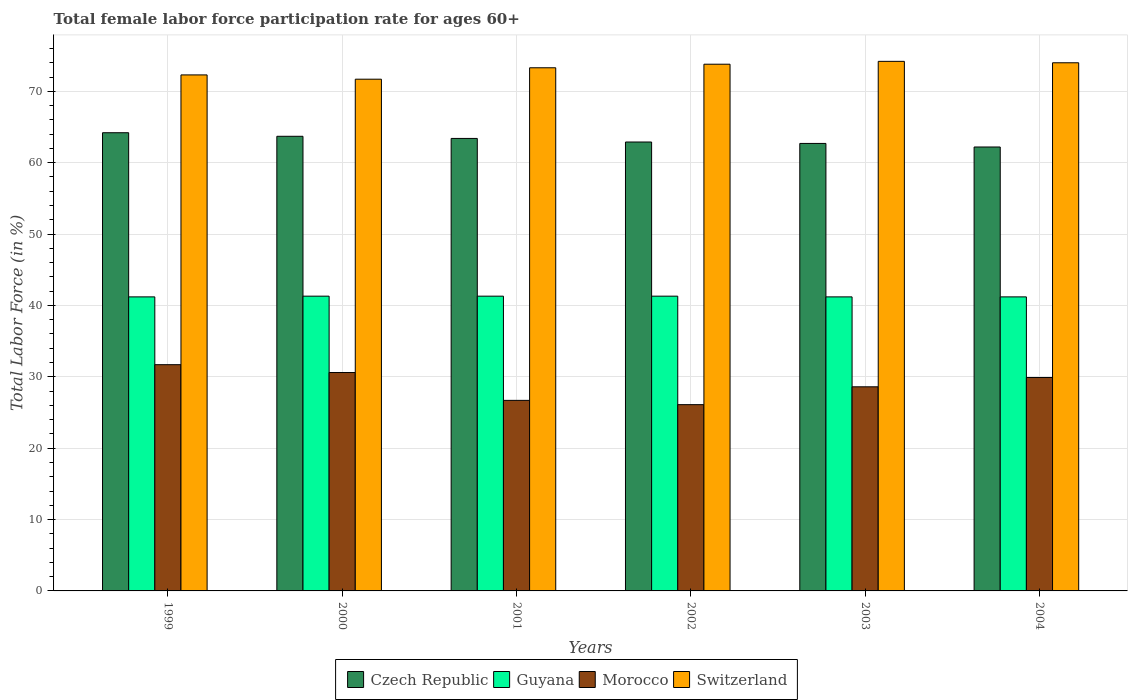How many different coloured bars are there?
Offer a terse response. 4. How many groups of bars are there?
Offer a very short reply. 6. Are the number of bars per tick equal to the number of legend labels?
Your answer should be compact. Yes. Are the number of bars on each tick of the X-axis equal?
Make the answer very short. Yes. How many bars are there on the 6th tick from the left?
Your answer should be very brief. 4. What is the label of the 1st group of bars from the left?
Give a very brief answer. 1999. What is the female labor force participation rate in Morocco in 2003?
Your answer should be compact. 28.6. Across all years, what is the maximum female labor force participation rate in Morocco?
Offer a terse response. 31.7. Across all years, what is the minimum female labor force participation rate in Morocco?
Ensure brevity in your answer.  26.1. In which year was the female labor force participation rate in Czech Republic maximum?
Offer a terse response. 1999. What is the total female labor force participation rate in Guyana in the graph?
Offer a terse response. 247.5. What is the difference between the female labor force participation rate in Morocco in 2000 and the female labor force participation rate in Switzerland in 2001?
Make the answer very short. -42.7. What is the average female labor force participation rate in Switzerland per year?
Ensure brevity in your answer.  73.22. In the year 2001, what is the difference between the female labor force participation rate in Guyana and female labor force participation rate in Czech Republic?
Provide a short and direct response. -22.1. What is the ratio of the female labor force participation rate in Guyana in 2001 to that in 2003?
Ensure brevity in your answer.  1. Is the difference between the female labor force participation rate in Guyana in 2001 and 2004 greater than the difference between the female labor force participation rate in Czech Republic in 2001 and 2004?
Your answer should be compact. No. What is the difference between the highest and the lowest female labor force participation rate in Czech Republic?
Offer a very short reply. 2. Is it the case that in every year, the sum of the female labor force participation rate in Czech Republic and female labor force participation rate in Switzerland is greater than the sum of female labor force participation rate in Morocco and female labor force participation rate in Guyana?
Your answer should be compact. Yes. What does the 3rd bar from the left in 2004 represents?
Offer a terse response. Morocco. What does the 4th bar from the right in 1999 represents?
Your response must be concise. Czech Republic. Is it the case that in every year, the sum of the female labor force participation rate in Czech Republic and female labor force participation rate in Switzerland is greater than the female labor force participation rate in Morocco?
Make the answer very short. Yes. How many bars are there?
Offer a very short reply. 24. What is the difference between two consecutive major ticks on the Y-axis?
Offer a terse response. 10. Are the values on the major ticks of Y-axis written in scientific E-notation?
Offer a terse response. No. Does the graph contain any zero values?
Your answer should be compact. No. Where does the legend appear in the graph?
Offer a very short reply. Bottom center. How many legend labels are there?
Provide a succinct answer. 4. How are the legend labels stacked?
Offer a very short reply. Horizontal. What is the title of the graph?
Ensure brevity in your answer.  Total female labor force participation rate for ages 60+. Does "Eritrea" appear as one of the legend labels in the graph?
Offer a very short reply. No. What is the label or title of the X-axis?
Your response must be concise. Years. What is the label or title of the Y-axis?
Provide a succinct answer. Total Labor Force (in %). What is the Total Labor Force (in %) in Czech Republic in 1999?
Provide a succinct answer. 64.2. What is the Total Labor Force (in %) of Guyana in 1999?
Ensure brevity in your answer.  41.2. What is the Total Labor Force (in %) in Morocco in 1999?
Keep it short and to the point. 31.7. What is the Total Labor Force (in %) of Switzerland in 1999?
Your answer should be compact. 72.3. What is the Total Labor Force (in %) of Czech Republic in 2000?
Provide a succinct answer. 63.7. What is the Total Labor Force (in %) of Guyana in 2000?
Provide a short and direct response. 41.3. What is the Total Labor Force (in %) of Morocco in 2000?
Your answer should be compact. 30.6. What is the Total Labor Force (in %) of Switzerland in 2000?
Provide a succinct answer. 71.7. What is the Total Labor Force (in %) of Czech Republic in 2001?
Offer a very short reply. 63.4. What is the Total Labor Force (in %) of Guyana in 2001?
Keep it short and to the point. 41.3. What is the Total Labor Force (in %) of Morocco in 2001?
Offer a very short reply. 26.7. What is the Total Labor Force (in %) in Switzerland in 2001?
Give a very brief answer. 73.3. What is the Total Labor Force (in %) in Czech Republic in 2002?
Offer a very short reply. 62.9. What is the Total Labor Force (in %) of Guyana in 2002?
Give a very brief answer. 41.3. What is the Total Labor Force (in %) of Morocco in 2002?
Offer a terse response. 26.1. What is the Total Labor Force (in %) of Switzerland in 2002?
Make the answer very short. 73.8. What is the Total Labor Force (in %) in Czech Republic in 2003?
Keep it short and to the point. 62.7. What is the Total Labor Force (in %) of Guyana in 2003?
Provide a succinct answer. 41.2. What is the Total Labor Force (in %) in Morocco in 2003?
Provide a succinct answer. 28.6. What is the Total Labor Force (in %) in Switzerland in 2003?
Provide a succinct answer. 74.2. What is the Total Labor Force (in %) of Czech Republic in 2004?
Provide a short and direct response. 62.2. What is the Total Labor Force (in %) of Guyana in 2004?
Your response must be concise. 41.2. What is the Total Labor Force (in %) of Morocco in 2004?
Your answer should be very brief. 29.9. What is the Total Labor Force (in %) of Switzerland in 2004?
Ensure brevity in your answer.  74. Across all years, what is the maximum Total Labor Force (in %) in Czech Republic?
Keep it short and to the point. 64.2. Across all years, what is the maximum Total Labor Force (in %) of Guyana?
Give a very brief answer. 41.3. Across all years, what is the maximum Total Labor Force (in %) in Morocco?
Make the answer very short. 31.7. Across all years, what is the maximum Total Labor Force (in %) of Switzerland?
Your response must be concise. 74.2. Across all years, what is the minimum Total Labor Force (in %) of Czech Republic?
Make the answer very short. 62.2. Across all years, what is the minimum Total Labor Force (in %) in Guyana?
Your answer should be compact. 41.2. Across all years, what is the minimum Total Labor Force (in %) of Morocco?
Ensure brevity in your answer.  26.1. Across all years, what is the minimum Total Labor Force (in %) of Switzerland?
Ensure brevity in your answer.  71.7. What is the total Total Labor Force (in %) of Czech Republic in the graph?
Your answer should be very brief. 379.1. What is the total Total Labor Force (in %) of Guyana in the graph?
Give a very brief answer. 247.5. What is the total Total Labor Force (in %) in Morocco in the graph?
Your answer should be compact. 173.6. What is the total Total Labor Force (in %) of Switzerland in the graph?
Keep it short and to the point. 439.3. What is the difference between the Total Labor Force (in %) of Morocco in 1999 and that in 2000?
Give a very brief answer. 1.1. What is the difference between the Total Labor Force (in %) of Switzerland in 1999 and that in 2000?
Give a very brief answer. 0.6. What is the difference between the Total Labor Force (in %) in Guyana in 1999 and that in 2001?
Your response must be concise. -0.1. What is the difference between the Total Labor Force (in %) in Czech Republic in 1999 and that in 2002?
Ensure brevity in your answer.  1.3. What is the difference between the Total Labor Force (in %) in Switzerland in 1999 and that in 2002?
Give a very brief answer. -1.5. What is the difference between the Total Labor Force (in %) of Czech Republic in 1999 and that in 2003?
Give a very brief answer. 1.5. What is the difference between the Total Labor Force (in %) of Guyana in 1999 and that in 2003?
Provide a short and direct response. 0. What is the difference between the Total Labor Force (in %) of Guyana in 1999 and that in 2004?
Provide a succinct answer. 0. What is the difference between the Total Labor Force (in %) of Czech Republic in 2000 and that in 2001?
Give a very brief answer. 0.3. What is the difference between the Total Labor Force (in %) in Morocco in 2000 and that in 2001?
Keep it short and to the point. 3.9. What is the difference between the Total Labor Force (in %) in Morocco in 2000 and that in 2002?
Give a very brief answer. 4.5. What is the difference between the Total Labor Force (in %) in Czech Republic in 2000 and that in 2003?
Offer a terse response. 1. What is the difference between the Total Labor Force (in %) of Morocco in 2000 and that in 2004?
Your response must be concise. 0.7. What is the difference between the Total Labor Force (in %) of Morocco in 2001 and that in 2002?
Make the answer very short. 0.6. What is the difference between the Total Labor Force (in %) of Switzerland in 2001 and that in 2002?
Give a very brief answer. -0.5. What is the difference between the Total Labor Force (in %) in Czech Republic in 2001 and that in 2004?
Your answer should be very brief. 1.2. What is the difference between the Total Labor Force (in %) in Morocco in 2001 and that in 2004?
Provide a succinct answer. -3.2. What is the difference between the Total Labor Force (in %) of Switzerland in 2001 and that in 2004?
Make the answer very short. -0.7. What is the difference between the Total Labor Force (in %) in Switzerland in 2002 and that in 2003?
Keep it short and to the point. -0.4. What is the difference between the Total Labor Force (in %) of Czech Republic in 2002 and that in 2004?
Give a very brief answer. 0.7. What is the difference between the Total Labor Force (in %) in Guyana in 2002 and that in 2004?
Provide a short and direct response. 0.1. What is the difference between the Total Labor Force (in %) in Switzerland in 2003 and that in 2004?
Offer a terse response. 0.2. What is the difference between the Total Labor Force (in %) in Czech Republic in 1999 and the Total Labor Force (in %) in Guyana in 2000?
Make the answer very short. 22.9. What is the difference between the Total Labor Force (in %) of Czech Republic in 1999 and the Total Labor Force (in %) of Morocco in 2000?
Provide a short and direct response. 33.6. What is the difference between the Total Labor Force (in %) of Guyana in 1999 and the Total Labor Force (in %) of Switzerland in 2000?
Provide a short and direct response. -30.5. What is the difference between the Total Labor Force (in %) in Czech Republic in 1999 and the Total Labor Force (in %) in Guyana in 2001?
Provide a succinct answer. 22.9. What is the difference between the Total Labor Force (in %) in Czech Republic in 1999 and the Total Labor Force (in %) in Morocco in 2001?
Offer a very short reply. 37.5. What is the difference between the Total Labor Force (in %) of Guyana in 1999 and the Total Labor Force (in %) of Morocco in 2001?
Make the answer very short. 14.5. What is the difference between the Total Labor Force (in %) in Guyana in 1999 and the Total Labor Force (in %) in Switzerland in 2001?
Offer a terse response. -32.1. What is the difference between the Total Labor Force (in %) of Morocco in 1999 and the Total Labor Force (in %) of Switzerland in 2001?
Give a very brief answer. -41.6. What is the difference between the Total Labor Force (in %) in Czech Republic in 1999 and the Total Labor Force (in %) in Guyana in 2002?
Offer a terse response. 22.9. What is the difference between the Total Labor Force (in %) of Czech Republic in 1999 and the Total Labor Force (in %) of Morocco in 2002?
Offer a terse response. 38.1. What is the difference between the Total Labor Force (in %) of Guyana in 1999 and the Total Labor Force (in %) of Switzerland in 2002?
Ensure brevity in your answer.  -32.6. What is the difference between the Total Labor Force (in %) of Morocco in 1999 and the Total Labor Force (in %) of Switzerland in 2002?
Ensure brevity in your answer.  -42.1. What is the difference between the Total Labor Force (in %) of Czech Republic in 1999 and the Total Labor Force (in %) of Guyana in 2003?
Give a very brief answer. 23. What is the difference between the Total Labor Force (in %) of Czech Republic in 1999 and the Total Labor Force (in %) of Morocco in 2003?
Your answer should be very brief. 35.6. What is the difference between the Total Labor Force (in %) in Czech Republic in 1999 and the Total Labor Force (in %) in Switzerland in 2003?
Provide a short and direct response. -10. What is the difference between the Total Labor Force (in %) in Guyana in 1999 and the Total Labor Force (in %) in Morocco in 2003?
Offer a very short reply. 12.6. What is the difference between the Total Labor Force (in %) of Guyana in 1999 and the Total Labor Force (in %) of Switzerland in 2003?
Give a very brief answer. -33. What is the difference between the Total Labor Force (in %) of Morocco in 1999 and the Total Labor Force (in %) of Switzerland in 2003?
Provide a succinct answer. -42.5. What is the difference between the Total Labor Force (in %) of Czech Republic in 1999 and the Total Labor Force (in %) of Morocco in 2004?
Provide a succinct answer. 34.3. What is the difference between the Total Labor Force (in %) of Guyana in 1999 and the Total Labor Force (in %) of Switzerland in 2004?
Provide a succinct answer. -32.8. What is the difference between the Total Labor Force (in %) of Morocco in 1999 and the Total Labor Force (in %) of Switzerland in 2004?
Offer a terse response. -42.3. What is the difference between the Total Labor Force (in %) of Czech Republic in 2000 and the Total Labor Force (in %) of Guyana in 2001?
Your answer should be compact. 22.4. What is the difference between the Total Labor Force (in %) in Czech Republic in 2000 and the Total Labor Force (in %) in Switzerland in 2001?
Provide a short and direct response. -9.6. What is the difference between the Total Labor Force (in %) in Guyana in 2000 and the Total Labor Force (in %) in Switzerland in 2001?
Ensure brevity in your answer.  -32. What is the difference between the Total Labor Force (in %) of Morocco in 2000 and the Total Labor Force (in %) of Switzerland in 2001?
Make the answer very short. -42.7. What is the difference between the Total Labor Force (in %) of Czech Republic in 2000 and the Total Labor Force (in %) of Guyana in 2002?
Your answer should be compact. 22.4. What is the difference between the Total Labor Force (in %) in Czech Republic in 2000 and the Total Labor Force (in %) in Morocco in 2002?
Your response must be concise. 37.6. What is the difference between the Total Labor Force (in %) in Czech Republic in 2000 and the Total Labor Force (in %) in Switzerland in 2002?
Keep it short and to the point. -10.1. What is the difference between the Total Labor Force (in %) of Guyana in 2000 and the Total Labor Force (in %) of Morocco in 2002?
Provide a short and direct response. 15.2. What is the difference between the Total Labor Force (in %) in Guyana in 2000 and the Total Labor Force (in %) in Switzerland in 2002?
Ensure brevity in your answer.  -32.5. What is the difference between the Total Labor Force (in %) of Morocco in 2000 and the Total Labor Force (in %) of Switzerland in 2002?
Ensure brevity in your answer.  -43.2. What is the difference between the Total Labor Force (in %) of Czech Republic in 2000 and the Total Labor Force (in %) of Morocco in 2003?
Make the answer very short. 35.1. What is the difference between the Total Labor Force (in %) in Czech Republic in 2000 and the Total Labor Force (in %) in Switzerland in 2003?
Make the answer very short. -10.5. What is the difference between the Total Labor Force (in %) in Guyana in 2000 and the Total Labor Force (in %) in Morocco in 2003?
Make the answer very short. 12.7. What is the difference between the Total Labor Force (in %) of Guyana in 2000 and the Total Labor Force (in %) of Switzerland in 2003?
Your answer should be compact. -32.9. What is the difference between the Total Labor Force (in %) in Morocco in 2000 and the Total Labor Force (in %) in Switzerland in 2003?
Your answer should be very brief. -43.6. What is the difference between the Total Labor Force (in %) of Czech Republic in 2000 and the Total Labor Force (in %) of Morocco in 2004?
Your response must be concise. 33.8. What is the difference between the Total Labor Force (in %) of Guyana in 2000 and the Total Labor Force (in %) of Morocco in 2004?
Make the answer very short. 11.4. What is the difference between the Total Labor Force (in %) in Guyana in 2000 and the Total Labor Force (in %) in Switzerland in 2004?
Your answer should be very brief. -32.7. What is the difference between the Total Labor Force (in %) in Morocco in 2000 and the Total Labor Force (in %) in Switzerland in 2004?
Provide a short and direct response. -43.4. What is the difference between the Total Labor Force (in %) in Czech Republic in 2001 and the Total Labor Force (in %) in Guyana in 2002?
Keep it short and to the point. 22.1. What is the difference between the Total Labor Force (in %) of Czech Republic in 2001 and the Total Labor Force (in %) of Morocco in 2002?
Your answer should be compact. 37.3. What is the difference between the Total Labor Force (in %) of Czech Republic in 2001 and the Total Labor Force (in %) of Switzerland in 2002?
Ensure brevity in your answer.  -10.4. What is the difference between the Total Labor Force (in %) in Guyana in 2001 and the Total Labor Force (in %) in Switzerland in 2002?
Your response must be concise. -32.5. What is the difference between the Total Labor Force (in %) of Morocco in 2001 and the Total Labor Force (in %) of Switzerland in 2002?
Offer a terse response. -47.1. What is the difference between the Total Labor Force (in %) of Czech Republic in 2001 and the Total Labor Force (in %) of Morocco in 2003?
Your answer should be very brief. 34.8. What is the difference between the Total Labor Force (in %) in Czech Republic in 2001 and the Total Labor Force (in %) in Switzerland in 2003?
Ensure brevity in your answer.  -10.8. What is the difference between the Total Labor Force (in %) of Guyana in 2001 and the Total Labor Force (in %) of Morocco in 2003?
Ensure brevity in your answer.  12.7. What is the difference between the Total Labor Force (in %) in Guyana in 2001 and the Total Labor Force (in %) in Switzerland in 2003?
Provide a succinct answer. -32.9. What is the difference between the Total Labor Force (in %) of Morocco in 2001 and the Total Labor Force (in %) of Switzerland in 2003?
Provide a succinct answer. -47.5. What is the difference between the Total Labor Force (in %) of Czech Republic in 2001 and the Total Labor Force (in %) of Morocco in 2004?
Make the answer very short. 33.5. What is the difference between the Total Labor Force (in %) of Czech Republic in 2001 and the Total Labor Force (in %) of Switzerland in 2004?
Keep it short and to the point. -10.6. What is the difference between the Total Labor Force (in %) of Guyana in 2001 and the Total Labor Force (in %) of Morocco in 2004?
Provide a succinct answer. 11.4. What is the difference between the Total Labor Force (in %) of Guyana in 2001 and the Total Labor Force (in %) of Switzerland in 2004?
Provide a short and direct response. -32.7. What is the difference between the Total Labor Force (in %) of Morocco in 2001 and the Total Labor Force (in %) of Switzerland in 2004?
Give a very brief answer. -47.3. What is the difference between the Total Labor Force (in %) of Czech Republic in 2002 and the Total Labor Force (in %) of Guyana in 2003?
Keep it short and to the point. 21.7. What is the difference between the Total Labor Force (in %) of Czech Republic in 2002 and the Total Labor Force (in %) of Morocco in 2003?
Ensure brevity in your answer.  34.3. What is the difference between the Total Labor Force (in %) of Czech Republic in 2002 and the Total Labor Force (in %) of Switzerland in 2003?
Make the answer very short. -11.3. What is the difference between the Total Labor Force (in %) in Guyana in 2002 and the Total Labor Force (in %) in Morocco in 2003?
Make the answer very short. 12.7. What is the difference between the Total Labor Force (in %) in Guyana in 2002 and the Total Labor Force (in %) in Switzerland in 2003?
Give a very brief answer. -32.9. What is the difference between the Total Labor Force (in %) in Morocco in 2002 and the Total Labor Force (in %) in Switzerland in 2003?
Your answer should be compact. -48.1. What is the difference between the Total Labor Force (in %) of Czech Republic in 2002 and the Total Labor Force (in %) of Guyana in 2004?
Keep it short and to the point. 21.7. What is the difference between the Total Labor Force (in %) in Czech Republic in 2002 and the Total Labor Force (in %) in Switzerland in 2004?
Make the answer very short. -11.1. What is the difference between the Total Labor Force (in %) of Guyana in 2002 and the Total Labor Force (in %) of Switzerland in 2004?
Make the answer very short. -32.7. What is the difference between the Total Labor Force (in %) of Morocco in 2002 and the Total Labor Force (in %) of Switzerland in 2004?
Your answer should be very brief. -47.9. What is the difference between the Total Labor Force (in %) of Czech Republic in 2003 and the Total Labor Force (in %) of Morocco in 2004?
Offer a very short reply. 32.8. What is the difference between the Total Labor Force (in %) of Czech Republic in 2003 and the Total Labor Force (in %) of Switzerland in 2004?
Give a very brief answer. -11.3. What is the difference between the Total Labor Force (in %) in Guyana in 2003 and the Total Labor Force (in %) in Switzerland in 2004?
Offer a terse response. -32.8. What is the difference between the Total Labor Force (in %) of Morocco in 2003 and the Total Labor Force (in %) of Switzerland in 2004?
Provide a short and direct response. -45.4. What is the average Total Labor Force (in %) of Czech Republic per year?
Your answer should be very brief. 63.18. What is the average Total Labor Force (in %) of Guyana per year?
Offer a terse response. 41.25. What is the average Total Labor Force (in %) of Morocco per year?
Provide a succinct answer. 28.93. What is the average Total Labor Force (in %) in Switzerland per year?
Offer a very short reply. 73.22. In the year 1999, what is the difference between the Total Labor Force (in %) of Czech Republic and Total Labor Force (in %) of Morocco?
Provide a short and direct response. 32.5. In the year 1999, what is the difference between the Total Labor Force (in %) in Czech Republic and Total Labor Force (in %) in Switzerland?
Ensure brevity in your answer.  -8.1. In the year 1999, what is the difference between the Total Labor Force (in %) of Guyana and Total Labor Force (in %) of Switzerland?
Offer a very short reply. -31.1. In the year 1999, what is the difference between the Total Labor Force (in %) in Morocco and Total Labor Force (in %) in Switzerland?
Make the answer very short. -40.6. In the year 2000, what is the difference between the Total Labor Force (in %) in Czech Republic and Total Labor Force (in %) in Guyana?
Ensure brevity in your answer.  22.4. In the year 2000, what is the difference between the Total Labor Force (in %) of Czech Republic and Total Labor Force (in %) of Morocco?
Make the answer very short. 33.1. In the year 2000, what is the difference between the Total Labor Force (in %) of Guyana and Total Labor Force (in %) of Morocco?
Make the answer very short. 10.7. In the year 2000, what is the difference between the Total Labor Force (in %) in Guyana and Total Labor Force (in %) in Switzerland?
Your response must be concise. -30.4. In the year 2000, what is the difference between the Total Labor Force (in %) in Morocco and Total Labor Force (in %) in Switzerland?
Offer a terse response. -41.1. In the year 2001, what is the difference between the Total Labor Force (in %) in Czech Republic and Total Labor Force (in %) in Guyana?
Make the answer very short. 22.1. In the year 2001, what is the difference between the Total Labor Force (in %) of Czech Republic and Total Labor Force (in %) of Morocco?
Make the answer very short. 36.7. In the year 2001, what is the difference between the Total Labor Force (in %) in Czech Republic and Total Labor Force (in %) in Switzerland?
Provide a succinct answer. -9.9. In the year 2001, what is the difference between the Total Labor Force (in %) in Guyana and Total Labor Force (in %) in Morocco?
Provide a short and direct response. 14.6. In the year 2001, what is the difference between the Total Labor Force (in %) of Guyana and Total Labor Force (in %) of Switzerland?
Offer a very short reply. -32. In the year 2001, what is the difference between the Total Labor Force (in %) in Morocco and Total Labor Force (in %) in Switzerland?
Your response must be concise. -46.6. In the year 2002, what is the difference between the Total Labor Force (in %) of Czech Republic and Total Labor Force (in %) of Guyana?
Make the answer very short. 21.6. In the year 2002, what is the difference between the Total Labor Force (in %) of Czech Republic and Total Labor Force (in %) of Morocco?
Keep it short and to the point. 36.8. In the year 2002, what is the difference between the Total Labor Force (in %) of Czech Republic and Total Labor Force (in %) of Switzerland?
Provide a succinct answer. -10.9. In the year 2002, what is the difference between the Total Labor Force (in %) in Guyana and Total Labor Force (in %) in Morocco?
Your response must be concise. 15.2. In the year 2002, what is the difference between the Total Labor Force (in %) of Guyana and Total Labor Force (in %) of Switzerland?
Your answer should be very brief. -32.5. In the year 2002, what is the difference between the Total Labor Force (in %) in Morocco and Total Labor Force (in %) in Switzerland?
Give a very brief answer. -47.7. In the year 2003, what is the difference between the Total Labor Force (in %) of Czech Republic and Total Labor Force (in %) of Morocco?
Provide a succinct answer. 34.1. In the year 2003, what is the difference between the Total Labor Force (in %) in Czech Republic and Total Labor Force (in %) in Switzerland?
Offer a terse response. -11.5. In the year 2003, what is the difference between the Total Labor Force (in %) in Guyana and Total Labor Force (in %) in Morocco?
Offer a terse response. 12.6. In the year 2003, what is the difference between the Total Labor Force (in %) of Guyana and Total Labor Force (in %) of Switzerland?
Ensure brevity in your answer.  -33. In the year 2003, what is the difference between the Total Labor Force (in %) of Morocco and Total Labor Force (in %) of Switzerland?
Your answer should be very brief. -45.6. In the year 2004, what is the difference between the Total Labor Force (in %) in Czech Republic and Total Labor Force (in %) in Guyana?
Provide a short and direct response. 21. In the year 2004, what is the difference between the Total Labor Force (in %) in Czech Republic and Total Labor Force (in %) in Morocco?
Ensure brevity in your answer.  32.3. In the year 2004, what is the difference between the Total Labor Force (in %) in Czech Republic and Total Labor Force (in %) in Switzerland?
Ensure brevity in your answer.  -11.8. In the year 2004, what is the difference between the Total Labor Force (in %) of Guyana and Total Labor Force (in %) of Switzerland?
Make the answer very short. -32.8. In the year 2004, what is the difference between the Total Labor Force (in %) in Morocco and Total Labor Force (in %) in Switzerland?
Your response must be concise. -44.1. What is the ratio of the Total Labor Force (in %) in Morocco in 1999 to that in 2000?
Make the answer very short. 1.04. What is the ratio of the Total Labor Force (in %) of Switzerland in 1999 to that in 2000?
Your answer should be very brief. 1.01. What is the ratio of the Total Labor Force (in %) of Czech Republic in 1999 to that in 2001?
Give a very brief answer. 1.01. What is the ratio of the Total Labor Force (in %) of Guyana in 1999 to that in 2001?
Give a very brief answer. 1. What is the ratio of the Total Labor Force (in %) in Morocco in 1999 to that in 2001?
Offer a terse response. 1.19. What is the ratio of the Total Labor Force (in %) of Switzerland in 1999 to that in 2001?
Offer a terse response. 0.99. What is the ratio of the Total Labor Force (in %) of Czech Republic in 1999 to that in 2002?
Offer a very short reply. 1.02. What is the ratio of the Total Labor Force (in %) of Guyana in 1999 to that in 2002?
Make the answer very short. 1. What is the ratio of the Total Labor Force (in %) of Morocco in 1999 to that in 2002?
Offer a very short reply. 1.21. What is the ratio of the Total Labor Force (in %) in Switzerland in 1999 to that in 2002?
Make the answer very short. 0.98. What is the ratio of the Total Labor Force (in %) in Czech Republic in 1999 to that in 2003?
Your answer should be very brief. 1.02. What is the ratio of the Total Labor Force (in %) of Guyana in 1999 to that in 2003?
Offer a very short reply. 1. What is the ratio of the Total Labor Force (in %) of Morocco in 1999 to that in 2003?
Make the answer very short. 1.11. What is the ratio of the Total Labor Force (in %) of Switzerland in 1999 to that in 2003?
Make the answer very short. 0.97. What is the ratio of the Total Labor Force (in %) of Czech Republic in 1999 to that in 2004?
Keep it short and to the point. 1.03. What is the ratio of the Total Labor Force (in %) in Guyana in 1999 to that in 2004?
Your answer should be compact. 1. What is the ratio of the Total Labor Force (in %) of Morocco in 1999 to that in 2004?
Your answer should be compact. 1.06. What is the ratio of the Total Labor Force (in %) in Switzerland in 1999 to that in 2004?
Make the answer very short. 0.98. What is the ratio of the Total Labor Force (in %) in Guyana in 2000 to that in 2001?
Ensure brevity in your answer.  1. What is the ratio of the Total Labor Force (in %) of Morocco in 2000 to that in 2001?
Ensure brevity in your answer.  1.15. What is the ratio of the Total Labor Force (in %) of Switzerland in 2000 to that in 2001?
Make the answer very short. 0.98. What is the ratio of the Total Labor Force (in %) in Czech Republic in 2000 to that in 2002?
Make the answer very short. 1.01. What is the ratio of the Total Labor Force (in %) in Morocco in 2000 to that in 2002?
Keep it short and to the point. 1.17. What is the ratio of the Total Labor Force (in %) of Switzerland in 2000 to that in 2002?
Give a very brief answer. 0.97. What is the ratio of the Total Labor Force (in %) of Czech Republic in 2000 to that in 2003?
Your answer should be compact. 1.02. What is the ratio of the Total Labor Force (in %) in Morocco in 2000 to that in 2003?
Your response must be concise. 1.07. What is the ratio of the Total Labor Force (in %) of Switzerland in 2000 to that in 2003?
Keep it short and to the point. 0.97. What is the ratio of the Total Labor Force (in %) of Czech Republic in 2000 to that in 2004?
Your answer should be compact. 1.02. What is the ratio of the Total Labor Force (in %) in Morocco in 2000 to that in 2004?
Your response must be concise. 1.02. What is the ratio of the Total Labor Force (in %) of Switzerland in 2000 to that in 2004?
Your answer should be very brief. 0.97. What is the ratio of the Total Labor Force (in %) in Czech Republic in 2001 to that in 2002?
Offer a terse response. 1.01. What is the ratio of the Total Labor Force (in %) in Guyana in 2001 to that in 2002?
Your answer should be very brief. 1. What is the ratio of the Total Labor Force (in %) of Morocco in 2001 to that in 2002?
Keep it short and to the point. 1.02. What is the ratio of the Total Labor Force (in %) of Czech Republic in 2001 to that in 2003?
Your answer should be very brief. 1.01. What is the ratio of the Total Labor Force (in %) of Guyana in 2001 to that in 2003?
Your response must be concise. 1. What is the ratio of the Total Labor Force (in %) in Morocco in 2001 to that in 2003?
Your answer should be compact. 0.93. What is the ratio of the Total Labor Force (in %) in Switzerland in 2001 to that in 2003?
Offer a terse response. 0.99. What is the ratio of the Total Labor Force (in %) of Czech Republic in 2001 to that in 2004?
Keep it short and to the point. 1.02. What is the ratio of the Total Labor Force (in %) of Morocco in 2001 to that in 2004?
Provide a succinct answer. 0.89. What is the ratio of the Total Labor Force (in %) of Switzerland in 2001 to that in 2004?
Make the answer very short. 0.99. What is the ratio of the Total Labor Force (in %) of Guyana in 2002 to that in 2003?
Offer a very short reply. 1. What is the ratio of the Total Labor Force (in %) of Morocco in 2002 to that in 2003?
Give a very brief answer. 0.91. What is the ratio of the Total Labor Force (in %) in Czech Republic in 2002 to that in 2004?
Offer a terse response. 1.01. What is the ratio of the Total Labor Force (in %) of Morocco in 2002 to that in 2004?
Give a very brief answer. 0.87. What is the ratio of the Total Labor Force (in %) of Switzerland in 2002 to that in 2004?
Keep it short and to the point. 1. What is the ratio of the Total Labor Force (in %) in Guyana in 2003 to that in 2004?
Offer a terse response. 1. What is the ratio of the Total Labor Force (in %) of Morocco in 2003 to that in 2004?
Keep it short and to the point. 0.96. What is the ratio of the Total Labor Force (in %) in Switzerland in 2003 to that in 2004?
Make the answer very short. 1. What is the difference between the highest and the second highest Total Labor Force (in %) of Czech Republic?
Your answer should be compact. 0.5. What is the difference between the highest and the second highest Total Labor Force (in %) of Guyana?
Give a very brief answer. 0. What is the difference between the highest and the lowest Total Labor Force (in %) of Czech Republic?
Ensure brevity in your answer.  2. What is the difference between the highest and the lowest Total Labor Force (in %) in Guyana?
Offer a very short reply. 0.1. What is the difference between the highest and the lowest Total Labor Force (in %) of Morocco?
Make the answer very short. 5.6. 